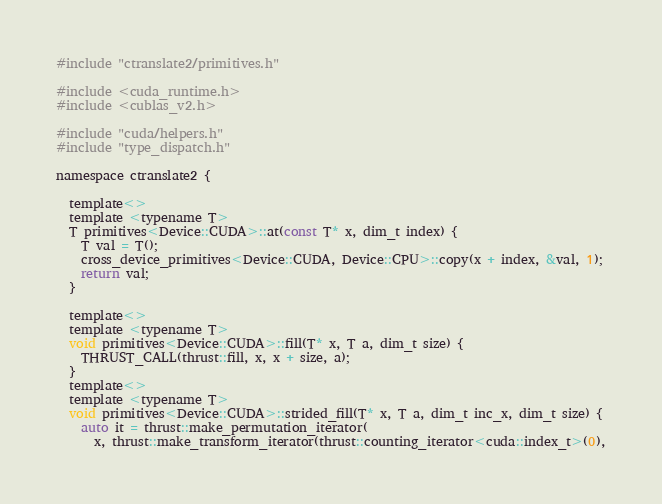Convert code to text. <code><loc_0><loc_0><loc_500><loc_500><_Cuda_>#include "ctranslate2/primitives.h"

#include <cuda_runtime.h>
#include <cublas_v2.h>

#include "cuda/helpers.h"
#include "type_dispatch.h"

namespace ctranslate2 {

  template<>
  template <typename T>
  T primitives<Device::CUDA>::at(const T* x, dim_t index) {
    T val = T();
    cross_device_primitives<Device::CUDA, Device::CPU>::copy(x + index, &val, 1);
    return val;
  }

  template<>
  template <typename T>
  void primitives<Device::CUDA>::fill(T* x, T a, dim_t size) {
    THRUST_CALL(thrust::fill, x, x + size, a);
  }
  template<>
  template <typename T>
  void primitives<Device::CUDA>::strided_fill(T* x, T a, dim_t inc_x, dim_t size) {
    auto it = thrust::make_permutation_iterator(
      x, thrust::make_transform_iterator(thrust::counting_iterator<cuda::index_t>(0),</code> 